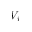<formula> <loc_0><loc_0><loc_500><loc_500>V _ { i }</formula> 